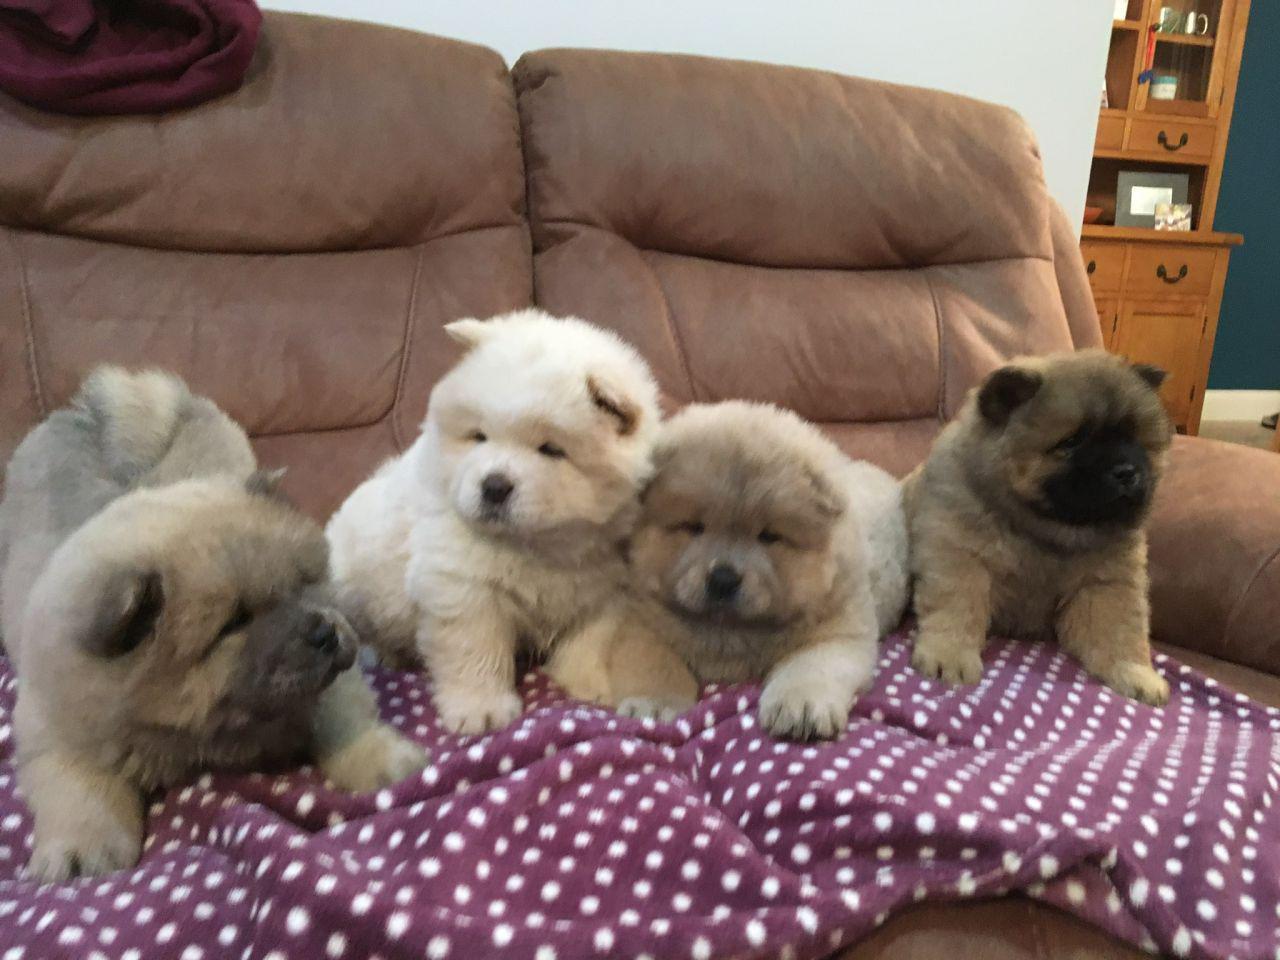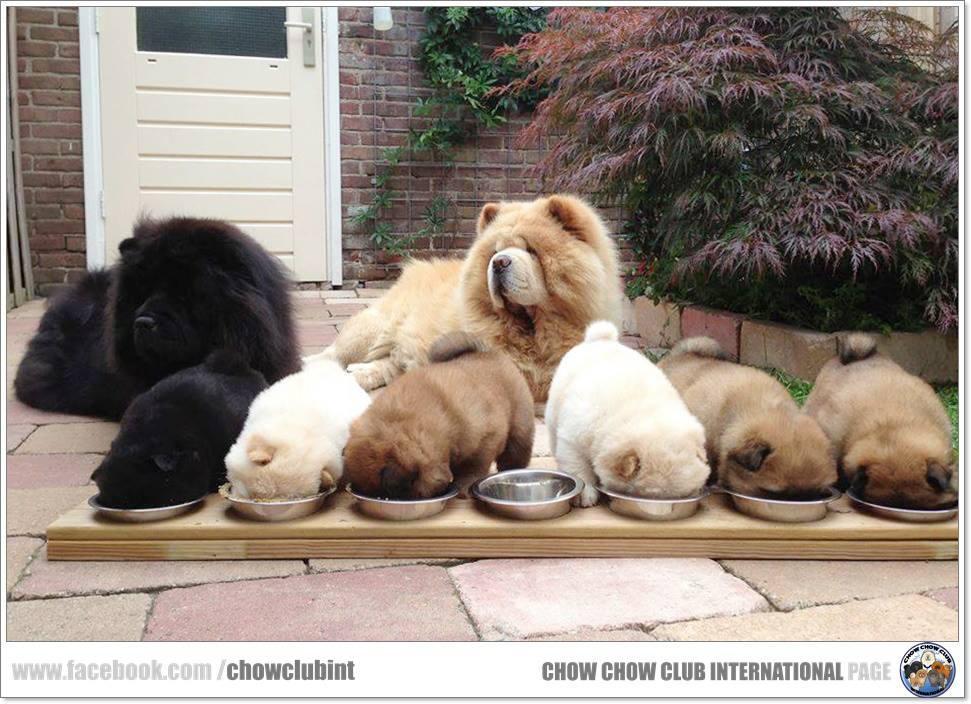The first image is the image on the left, the second image is the image on the right. Analyze the images presented: Is the assertion "Right and left images contain the same number of dogs." valid? Answer yes or no. No. The first image is the image on the left, the second image is the image on the right. Evaluate the accuracy of this statement regarding the images: "There are two dogs in total.". Is it true? Answer yes or no. No. 